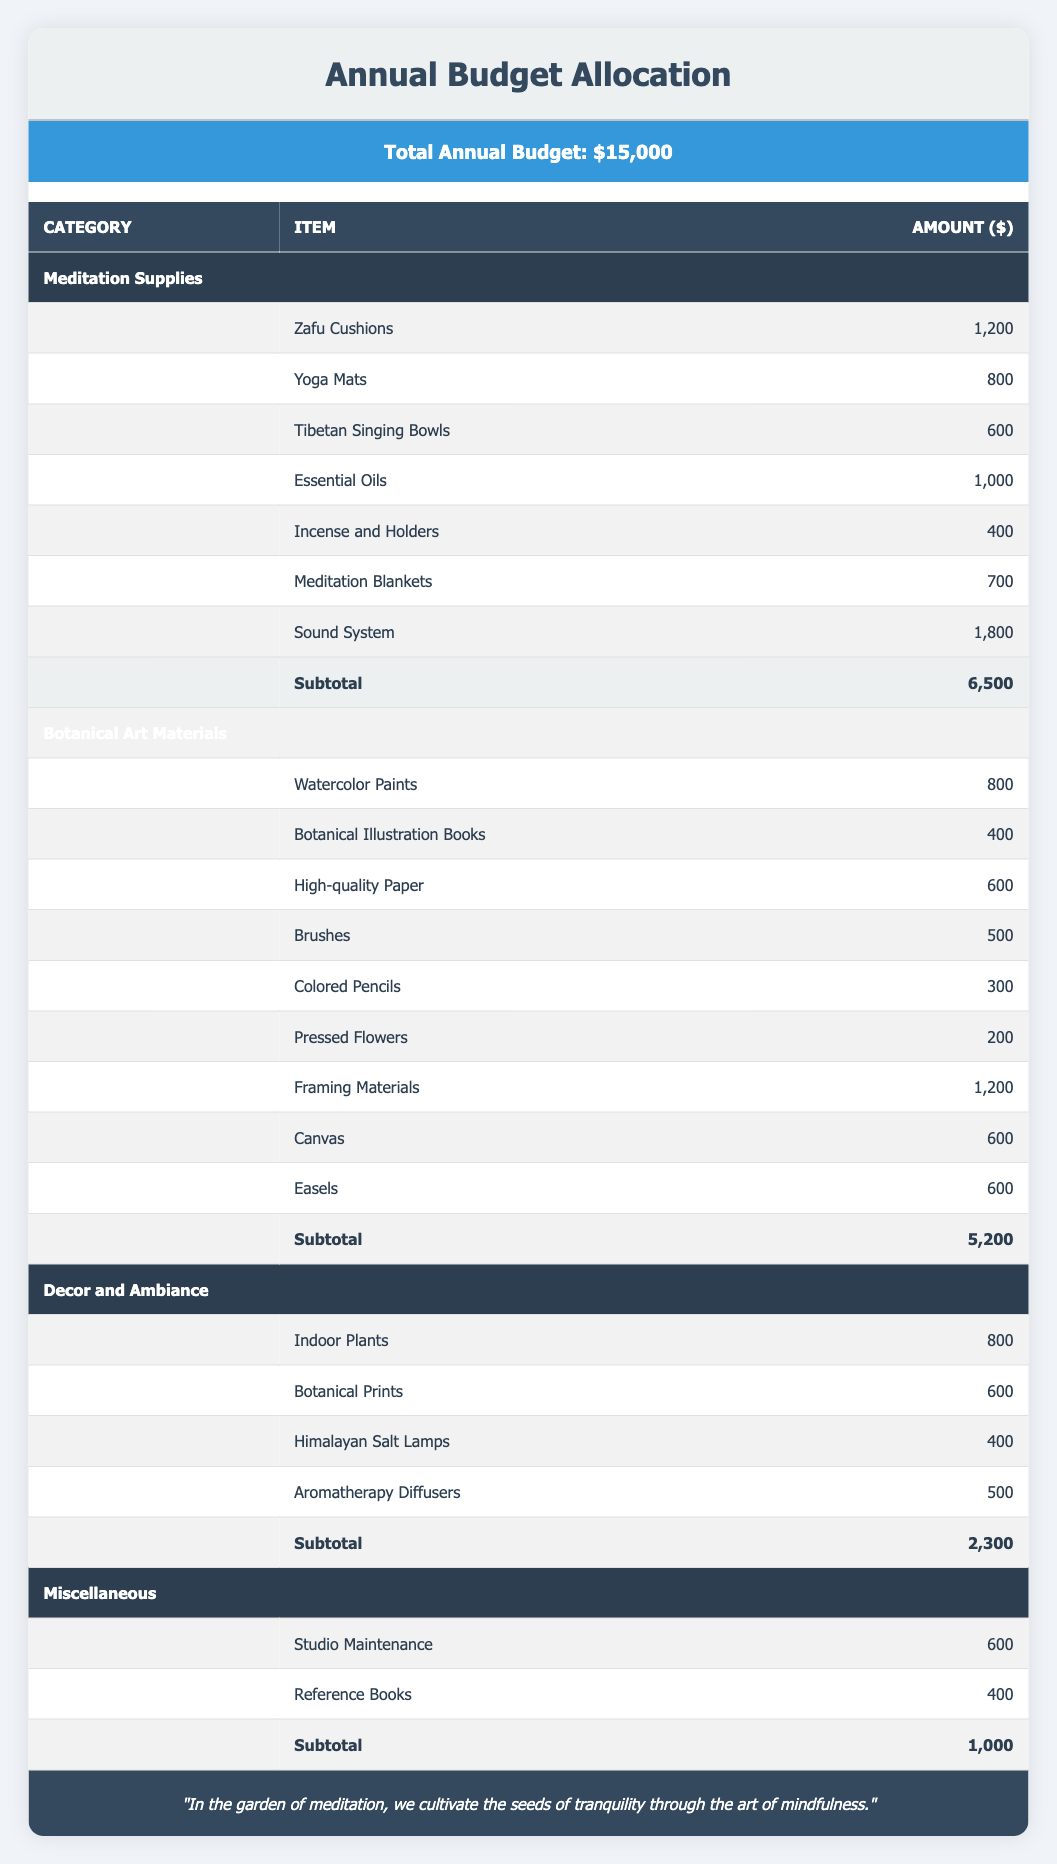What is the total amount allocated for Botanical Art Materials? The table indicates that the total for Botanical Art Materials is listed under that category and the amount is $5,200.
Answer: 5,200 How much was allocated for Essential Oils? Essential Oils are specifically mentioned under the Meditation Supplies category, and their allocated amount is $1,000.
Answer: 1,000 Is the amount for Indoor Plants greater than that for Colored Pencils? Indoor Plants are stated to cost $800, while Colored Pencils cost $300. Since $800 is greater than $300, the statement is true.
Answer: Yes What is the total expenditure for the Decor and Ambiance category? The total amount for Decor and Ambiance is given as $2,300 at the end of that section in the table.
Answer: 2,300 If we sum up the costs for all Meditation Supplies, is it more than $7,000? The total for Meditation Supplies is $6,500. Since $6,500 is less than $7,000, the answer is no. The individual items total can be computed and confirmed as accurate within the category.
Answer: No What is the most expensive item in the Botanical Art Materials category? The Framing Materials amount to $1,200, which is the highest among the items listed in the Botanical Art Materials category. Comparing it with other items reveals no higher amounts.
Answer: Framing Materials How much would be left from the total budget after accounting for Meditation Supplies and Botanical Art Materials? Subtract the totals of Meditation Supplies ($6,500) and Botanical Art Materials ($5,200) from the total budget of $15,000. The calculation is $15,000 - ($6,500 + $5,200) = $15,000 - $11,700 = $3,300.
Answer: 3,300 Are there more items in the Miscellaneous category than in the Decor and Ambiance category? The Miscellaneous category has 2 items (Studio Maintenance and Reference Books), while the Decor and Ambiance category contains 4 items (Indoor Plants, Botanical Prints, Himalayan Salt Lamps, and Aromatherapy Diffusers). Thus, there are fewer items in Miscellaneous.
Answer: No Which category has the highest total allocation? By comparing the total allocations across the categories outlined in the table, Meditation Supplies at $6,500 is the highest among them.
Answer: Meditation Supplies 